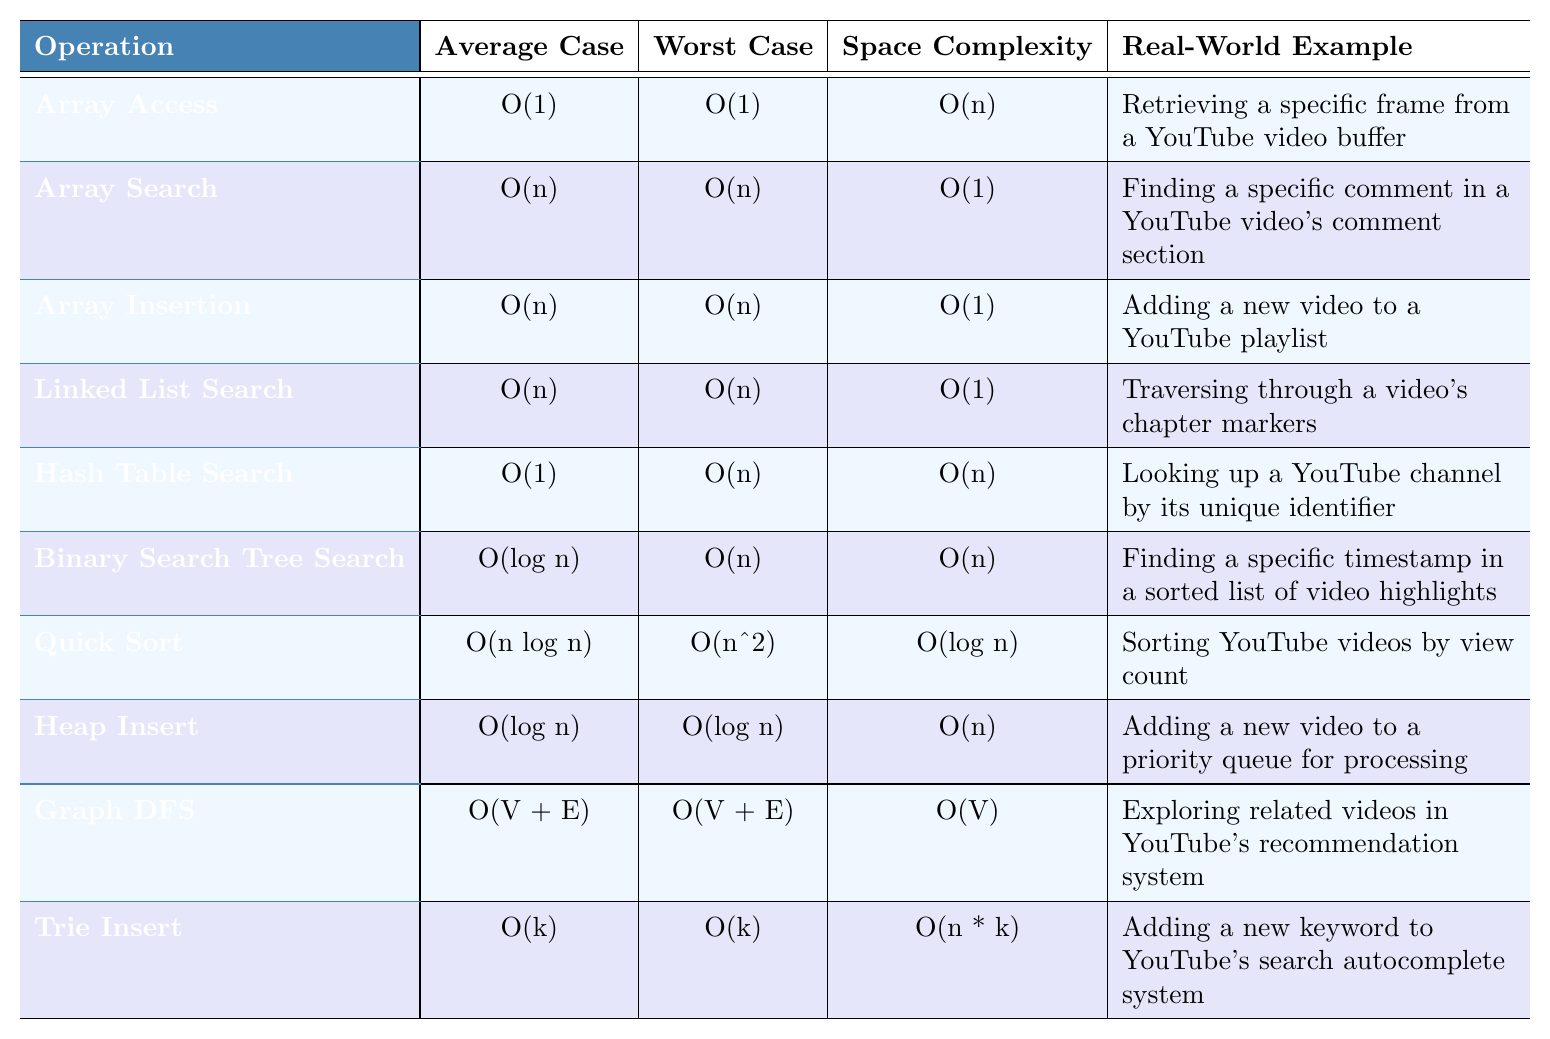What is the time complexity of Array Access in both average and worst cases? The table shows that both the average case and the worst case for Array Access are O(1).
Answer: O(1) What is the space complexity for the Hash Table Search operation? According to the table, the space complexity for Hash Table Search is O(n).
Answer: O(n) Which operation has the worst-case time complexity of O(n log n)? By reviewing the table, Quick Sort has a worst-case time complexity of O(n^2), not O(n log n). There are no operations listed with a worst-case of O(n log n).
Answer: No, none What is the real-world example for Trie Insert? The table provides that the real-world example for Trie Insert is adding a new keyword to YouTube's search autocomplete system.
Answer: Adding a new keyword to search autocomplete Which operation requires O(n) space complexity in the table? The table indicates that both Hash Table Search and Trie Insert operations have O(n) space complexity.
Answer: Hash Table Search and Trie Insert What is the difference between the average and worst-case time complexity for Binary Search Tree Search? The average case is O(log n) while the worst case is O(n). Therefore, the difference is O(n) - O(log n) but since we need to compare complexities, it's clear that O(n) is greater than O(log n).
Answer: O(n) - O(log n) shows worst case greater Can Graph DFS have more space complexity than any other operation listed? Looking at the table, the space complexity for Graph DFS is O(V), which could potentially be greater than the constant space complexities of other simpler operations, but the actual comparison requires context about V and n.
Answer: Not necessarily; it depends on the graph If an operation has an average case of O(n) and a worst case of O(n), what can you conclude about it? The table shows that the operation exhibits linear time complexity in both cases, indicating the performance remains consistent regardless of input conditions.
Answer: It has consistent linear complexity Which data structure operation performs best on average? From the table, Hash Table Search has the best average case complexity at O(1).
Answer: Hash Table Search How does the space complexity of Heap Insert compare to that of Array Insertion? The table states that Heap Insert has a space complexity of O(n), while Array Insertion has a space complexity of O(1). Hence, Heap Insert requires more space.
Answer: Heap Insert requires more space (O(n)) than Array Insertion (O(1)) What is the time complexity of Quick Sort in the worst-case scenario? According to the table, the worst-case time complexity of Quick Sort is O(n^2).
Answer: O(n^2) 